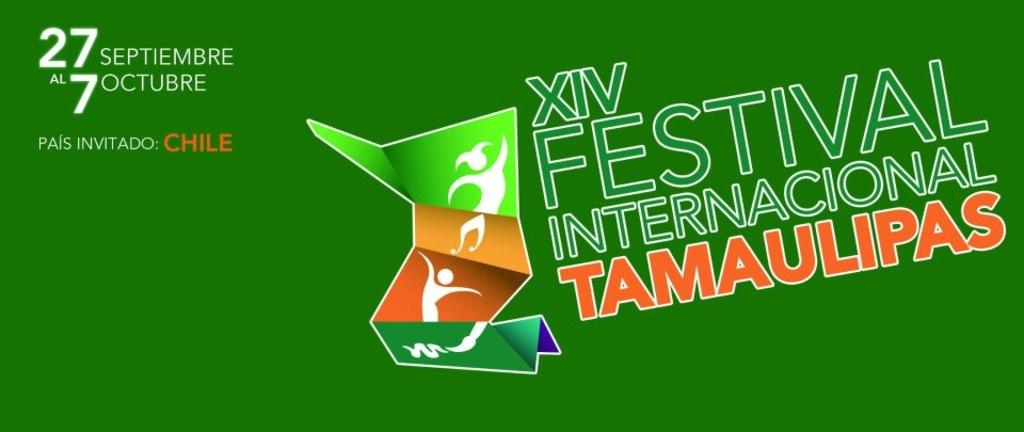Provide a one-sentence caption for the provided image. ad from xiv festival internacional tamaulipas om green. 